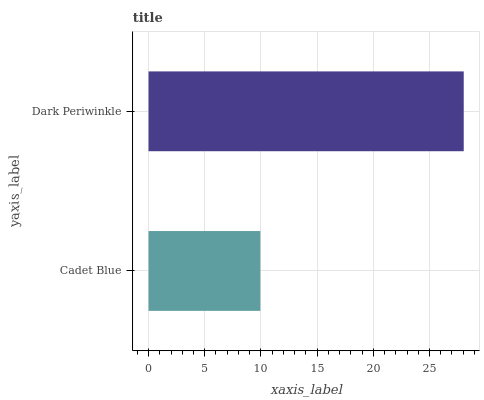Is Cadet Blue the minimum?
Answer yes or no. Yes. Is Dark Periwinkle the maximum?
Answer yes or no. Yes. Is Dark Periwinkle the minimum?
Answer yes or no. No. Is Dark Periwinkle greater than Cadet Blue?
Answer yes or no. Yes. Is Cadet Blue less than Dark Periwinkle?
Answer yes or no. Yes. Is Cadet Blue greater than Dark Periwinkle?
Answer yes or no. No. Is Dark Periwinkle less than Cadet Blue?
Answer yes or no. No. Is Dark Periwinkle the high median?
Answer yes or no. Yes. Is Cadet Blue the low median?
Answer yes or no. Yes. Is Cadet Blue the high median?
Answer yes or no. No. Is Dark Periwinkle the low median?
Answer yes or no. No. 